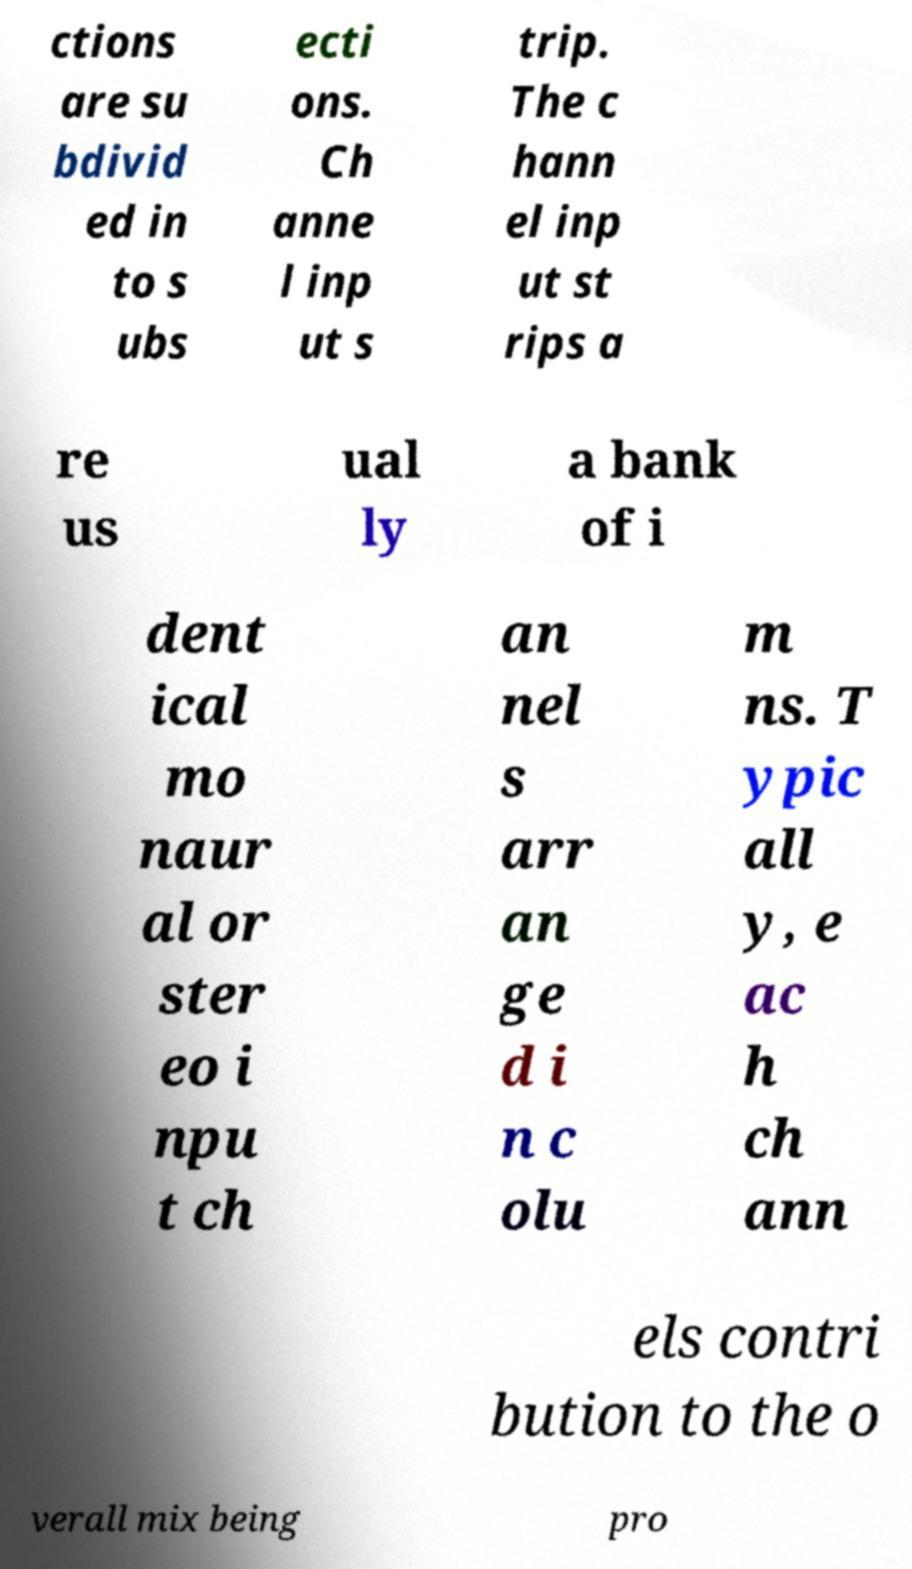Can you accurately transcribe the text from the provided image for me? ctions are su bdivid ed in to s ubs ecti ons. Ch anne l inp ut s trip. The c hann el inp ut st rips a re us ual ly a bank of i dent ical mo naur al or ster eo i npu t ch an nel s arr an ge d i n c olu m ns. T ypic all y, e ac h ch ann els contri bution to the o verall mix being pro 